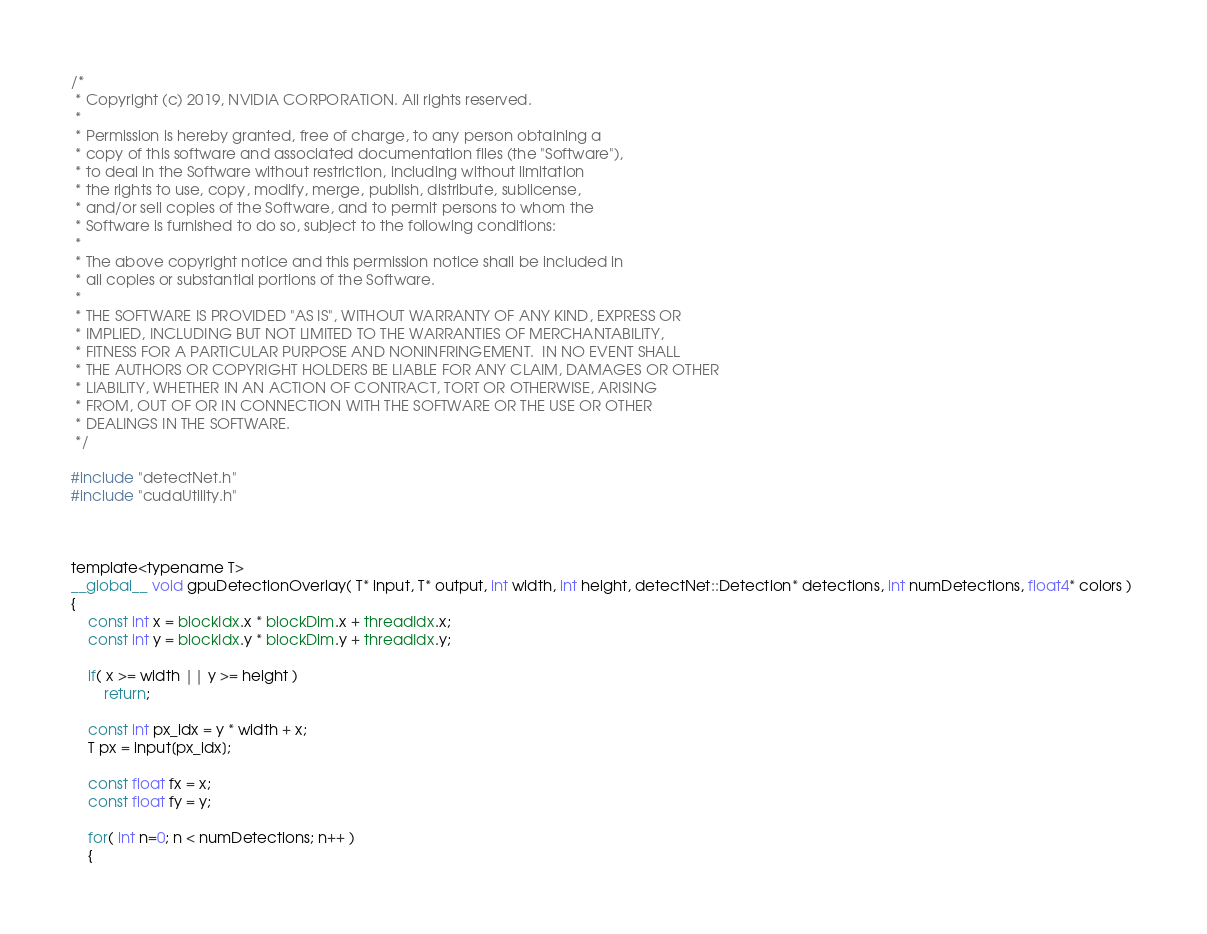Convert code to text. <code><loc_0><loc_0><loc_500><loc_500><_Cuda_>/*
 * Copyright (c) 2019, NVIDIA CORPORATION. All rights reserved.
 *
 * Permission is hereby granted, free of charge, to any person obtaining a
 * copy of this software and associated documentation files (the "Software"),
 * to deal in the Software without restriction, including without limitation
 * the rights to use, copy, modify, merge, publish, distribute, sublicense,
 * and/or sell copies of the Software, and to permit persons to whom the
 * Software is furnished to do so, subject to the following conditions:
 *
 * The above copyright notice and this permission notice shall be included in
 * all copies or substantial portions of the Software.
 *
 * THE SOFTWARE IS PROVIDED "AS IS", WITHOUT WARRANTY OF ANY KIND, EXPRESS OR
 * IMPLIED, INCLUDING BUT NOT LIMITED TO THE WARRANTIES OF MERCHANTABILITY,
 * FITNESS FOR A PARTICULAR PURPOSE AND NONINFRINGEMENT.  IN NO EVENT SHALL
 * THE AUTHORS OR COPYRIGHT HOLDERS BE LIABLE FOR ANY CLAIM, DAMAGES OR OTHER
 * LIABILITY, WHETHER IN AN ACTION OF CONTRACT, TORT OR OTHERWISE, ARISING
 * FROM, OUT OF OR IN CONNECTION WITH THE SOFTWARE OR THE USE OR OTHER
 * DEALINGS IN THE SOFTWARE.
 */

#include "detectNet.h"
#include "cudaUtility.h"



template<typename T>
__global__ void gpuDetectionOverlay( T* input, T* output, int width, int height, detectNet::Detection* detections, int numDetections, float4* colors ) 
{
	const int x = blockIdx.x * blockDim.x + threadIdx.x;
	const int y = blockIdx.y * blockDim.y + threadIdx.y;

	if( x >= width || y >= height )
		return;

	const int px_idx = y * width + x;
	T px = input[px_idx];
	
	const float fx = x;
	const float fy = y;
	
	for( int n=0; n < numDetections; n++ )
	{</code> 